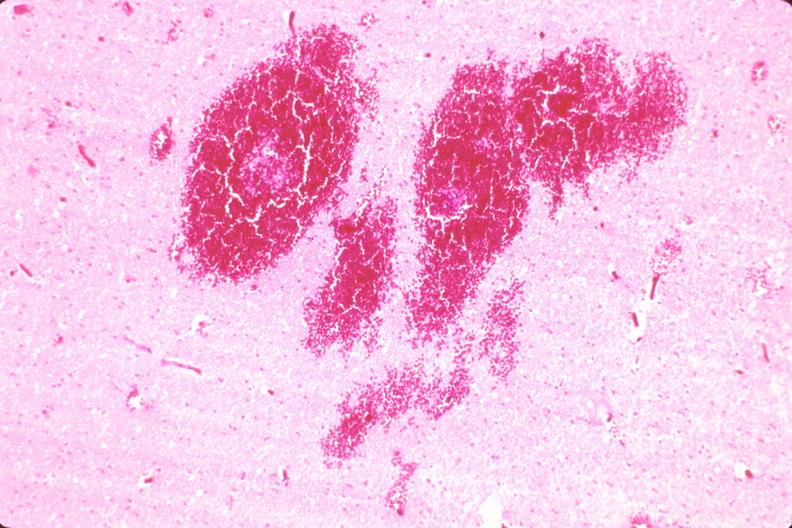does this image show brain, infarct and hemorrhage due to ruptured saccular aneurysm and thrombosis of right middle cerebral artery?
Answer the question using a single word or phrase. Yes 